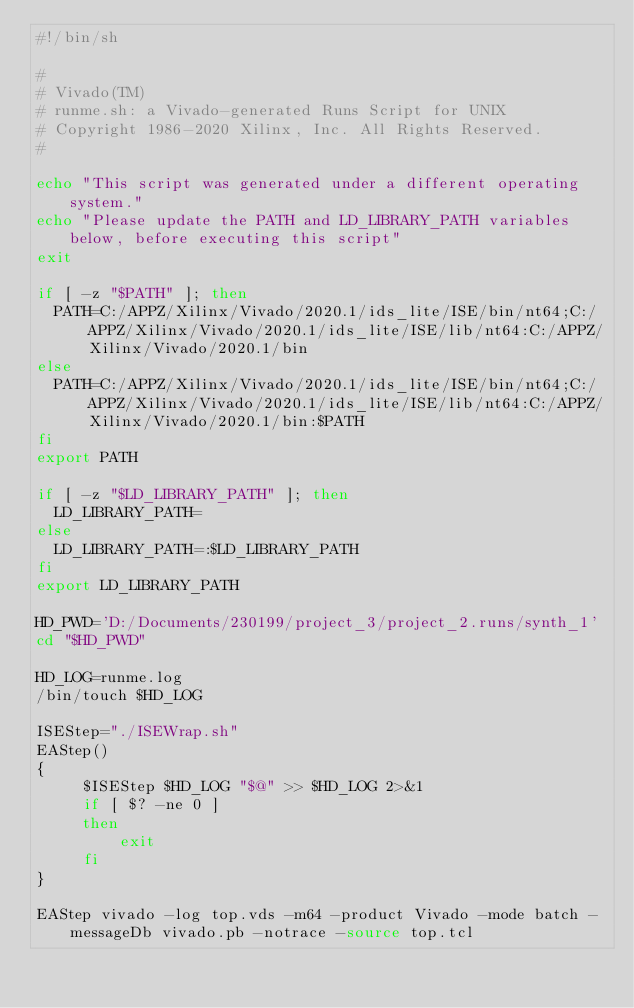Convert code to text. <code><loc_0><loc_0><loc_500><loc_500><_Bash_>#!/bin/sh

# 
# Vivado(TM)
# runme.sh: a Vivado-generated Runs Script for UNIX
# Copyright 1986-2020 Xilinx, Inc. All Rights Reserved.
# 

echo "This script was generated under a different operating system."
echo "Please update the PATH and LD_LIBRARY_PATH variables below, before executing this script"
exit

if [ -z "$PATH" ]; then
  PATH=C:/APPZ/Xilinx/Vivado/2020.1/ids_lite/ISE/bin/nt64;C:/APPZ/Xilinx/Vivado/2020.1/ids_lite/ISE/lib/nt64:C:/APPZ/Xilinx/Vivado/2020.1/bin
else
  PATH=C:/APPZ/Xilinx/Vivado/2020.1/ids_lite/ISE/bin/nt64;C:/APPZ/Xilinx/Vivado/2020.1/ids_lite/ISE/lib/nt64:C:/APPZ/Xilinx/Vivado/2020.1/bin:$PATH
fi
export PATH

if [ -z "$LD_LIBRARY_PATH" ]; then
  LD_LIBRARY_PATH=
else
  LD_LIBRARY_PATH=:$LD_LIBRARY_PATH
fi
export LD_LIBRARY_PATH

HD_PWD='D:/Documents/230199/project_3/project_2.runs/synth_1'
cd "$HD_PWD"

HD_LOG=runme.log
/bin/touch $HD_LOG

ISEStep="./ISEWrap.sh"
EAStep()
{
     $ISEStep $HD_LOG "$@" >> $HD_LOG 2>&1
     if [ $? -ne 0 ]
     then
         exit
     fi
}

EAStep vivado -log top.vds -m64 -product Vivado -mode batch -messageDb vivado.pb -notrace -source top.tcl
</code> 